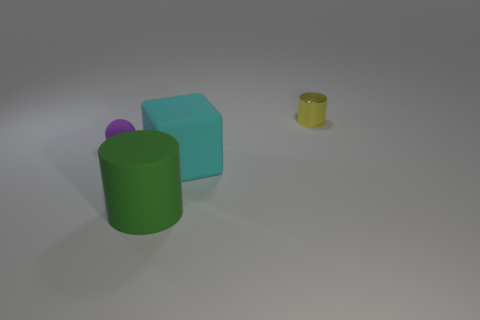How many objects are either rubber things that are to the right of the tiny matte ball or large things to the left of the cube?
Keep it short and to the point. 2. The small matte sphere is what color?
Ensure brevity in your answer.  Purple. How many purple objects have the same material as the green object?
Ensure brevity in your answer.  1. Are there more cyan objects than tiny rubber cylinders?
Ensure brevity in your answer.  Yes. What number of balls are behind the big rubber object that is behind the matte cylinder?
Your answer should be compact. 1. How many objects are big matte things behind the big cylinder or purple metallic objects?
Ensure brevity in your answer.  1. Are there any cyan rubber objects that have the same shape as the small yellow object?
Give a very brief answer. No. There is a metallic thing behind the rubber object that is in front of the large cyan object; what shape is it?
Your answer should be very brief. Cylinder. How many balls are either small matte things or big matte things?
Make the answer very short. 1. There is a small thing that is to the right of the matte cube; is its shape the same as the small object to the left of the cube?
Your answer should be compact. No. 